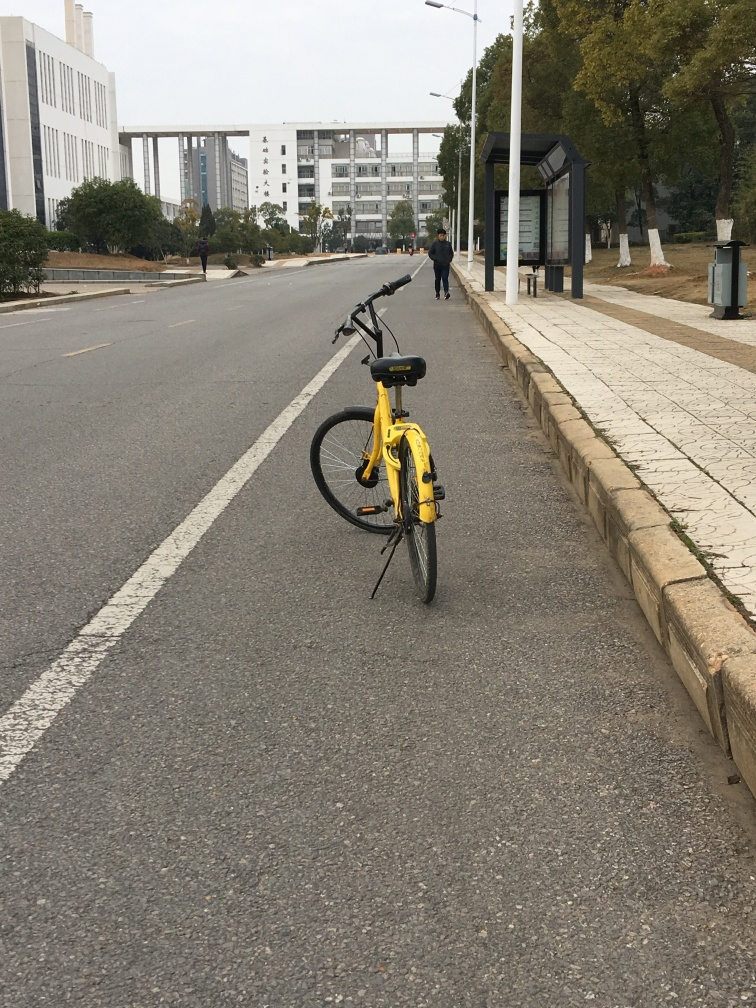What can this photo tell us about the location's urban planning? The photo shows a well-structured setting with a clean, wide road, designated bike lanes, orderly sidewalks, and a bus stop. These elements reflect a thoughtful urban design that prioritizes accessibility and transportation options for pedestrians and cyclists alike. 